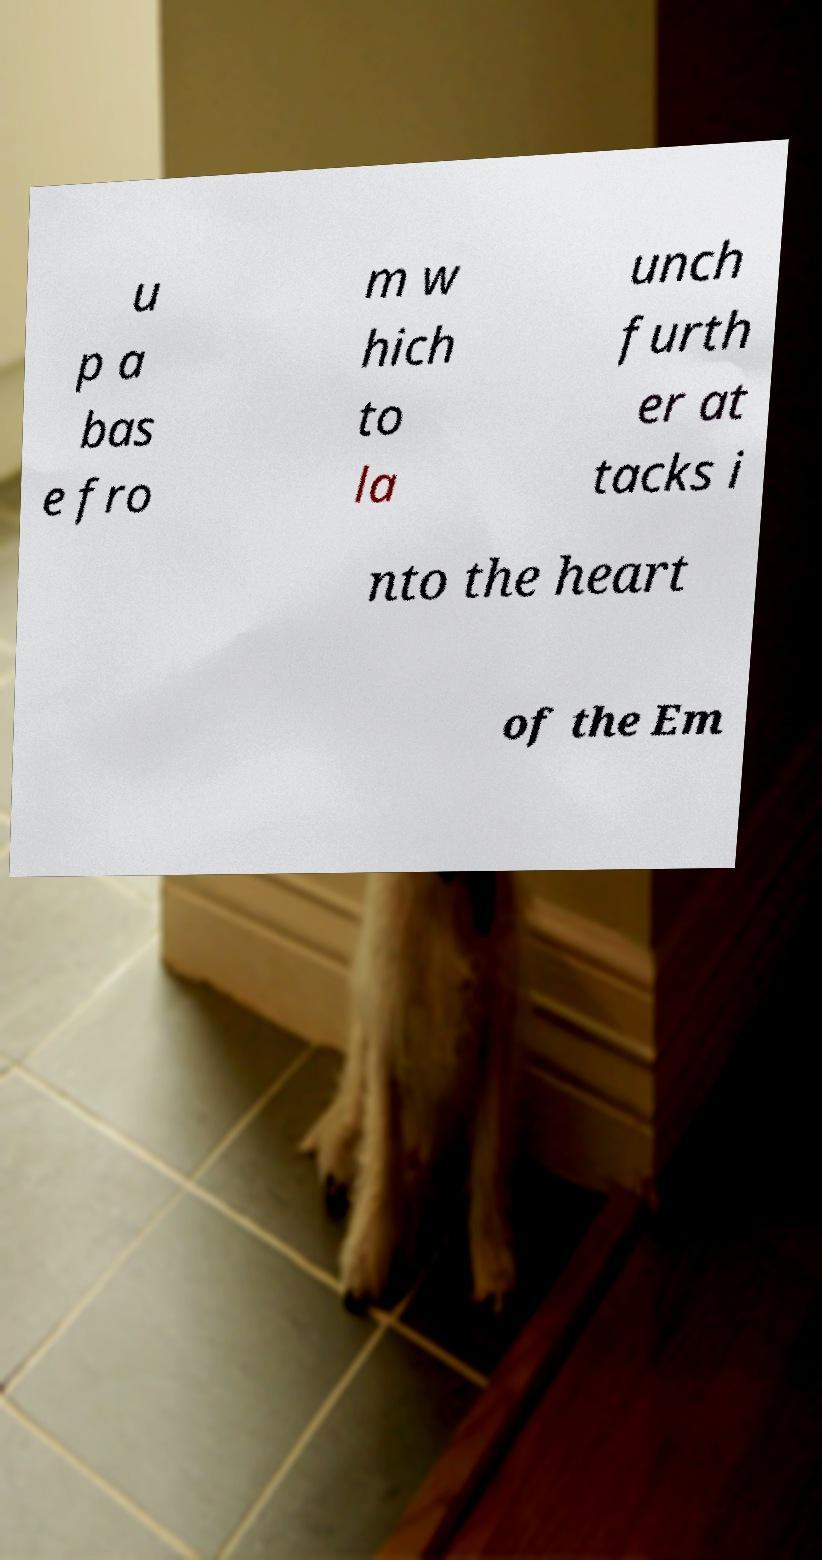Could you assist in decoding the text presented in this image and type it out clearly? u p a bas e fro m w hich to la unch furth er at tacks i nto the heart of the Em 